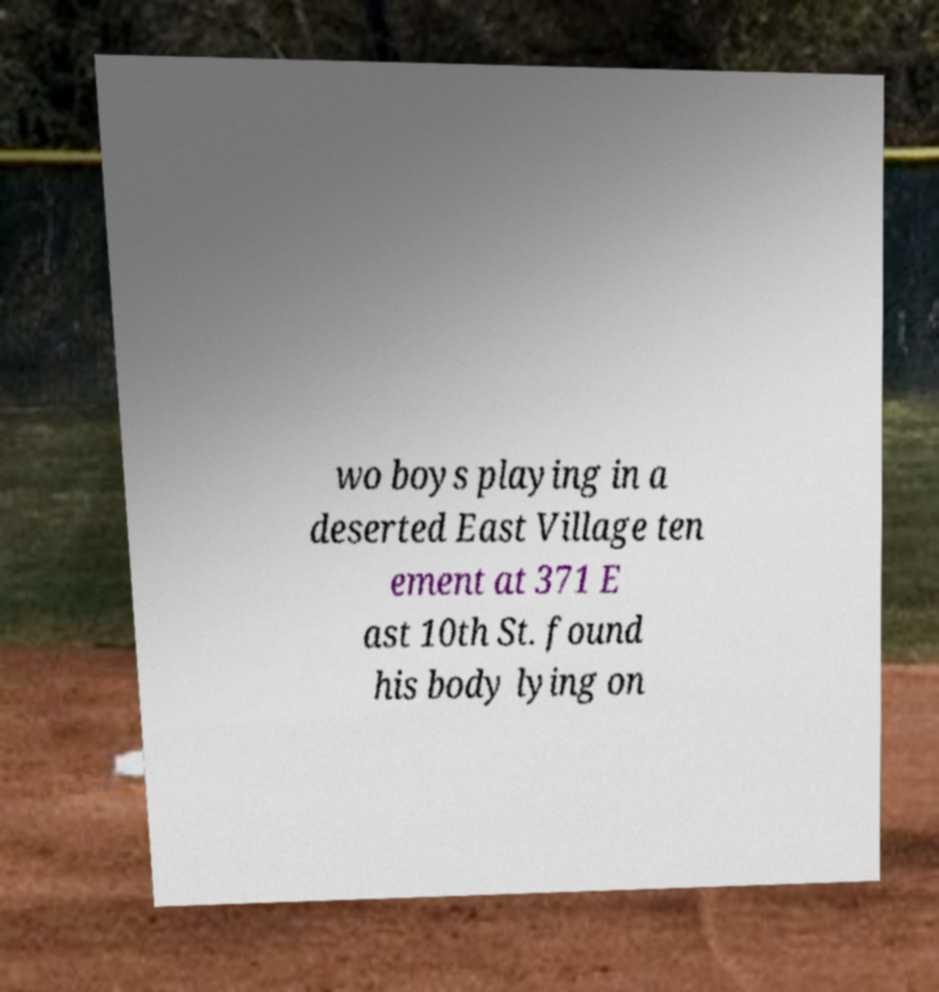Can you read and provide the text displayed in the image?This photo seems to have some interesting text. Can you extract and type it out for me? wo boys playing in a deserted East Village ten ement at 371 E ast 10th St. found his body lying on 